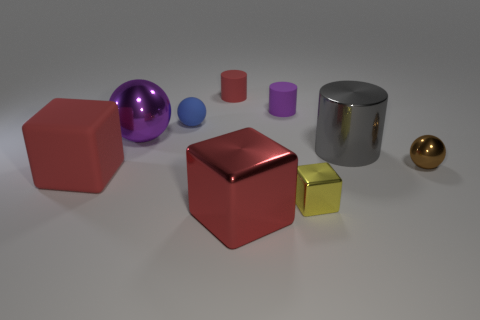Add 1 green balls. How many objects exist? 10 Subtract all cylinders. How many objects are left? 6 Subtract all large yellow rubber cylinders. Subtract all tiny yellow metallic things. How many objects are left? 8 Add 5 tiny cylinders. How many tiny cylinders are left? 7 Add 5 small purple things. How many small purple things exist? 6 Subtract 0 blue cylinders. How many objects are left? 9 